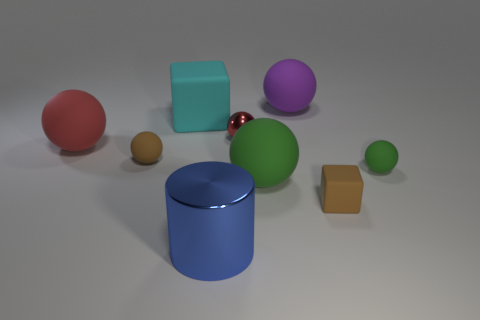Is the color of the sphere that is to the left of the tiny brown ball the same as the shiny cylinder left of the purple matte object? No, the colors are different. The sphere to the left of the tiny brown ball is a red hue, whereas the shiny cylinder to the left of the purple matte object is blue. 